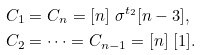<formula> <loc_0><loc_0><loc_500><loc_500>& C _ { 1 } = C _ { n } = [ n ] \ \sigma ^ { t _ { 2 } } [ n - 3 ] , \quad \\ & C _ { 2 } = \dots = C _ { n - 1 } = [ n ] \ [ 1 ] .</formula> 